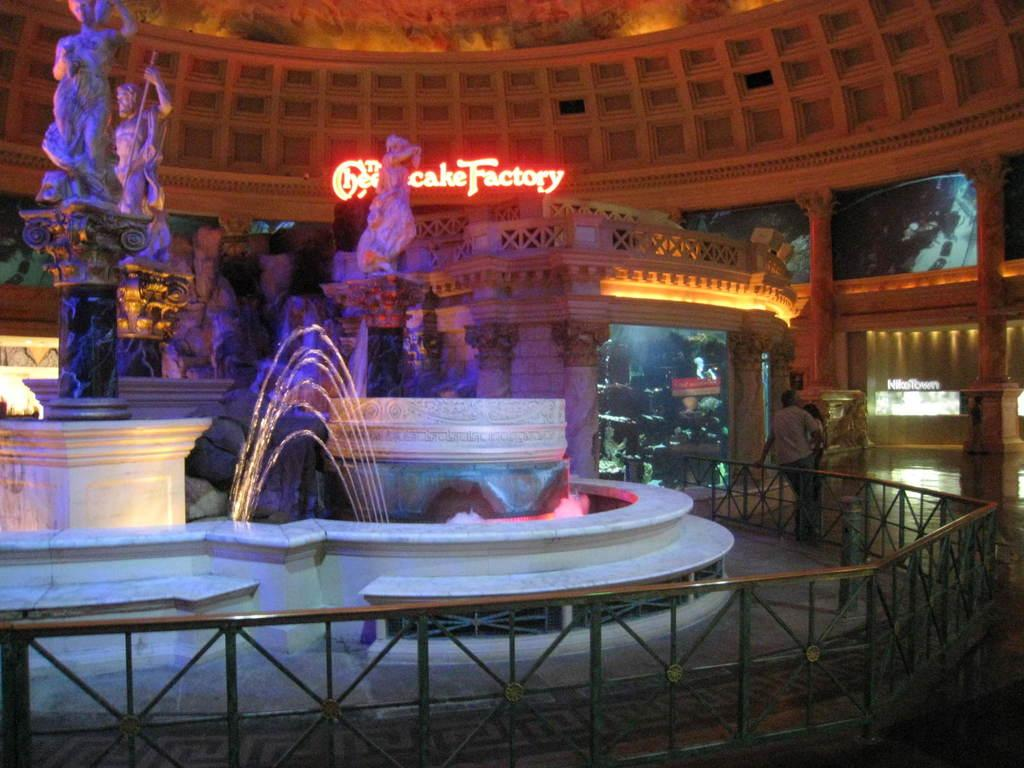What type of location is depicted in the image? The image is an inside picture of a factory. What kind of objects can be seen in the factory? There are sculptures and pillars in the image. Are there any people present in the image? Yes, there are persons in the image. What architectural feature is visible in the image? There is a fence in the image. What additional feature can be seen in the factory? There is a water fountain in the image. What type of poison is being used in the factory, as seen in the image? There is no indication of poison being used in the factory in the image. 